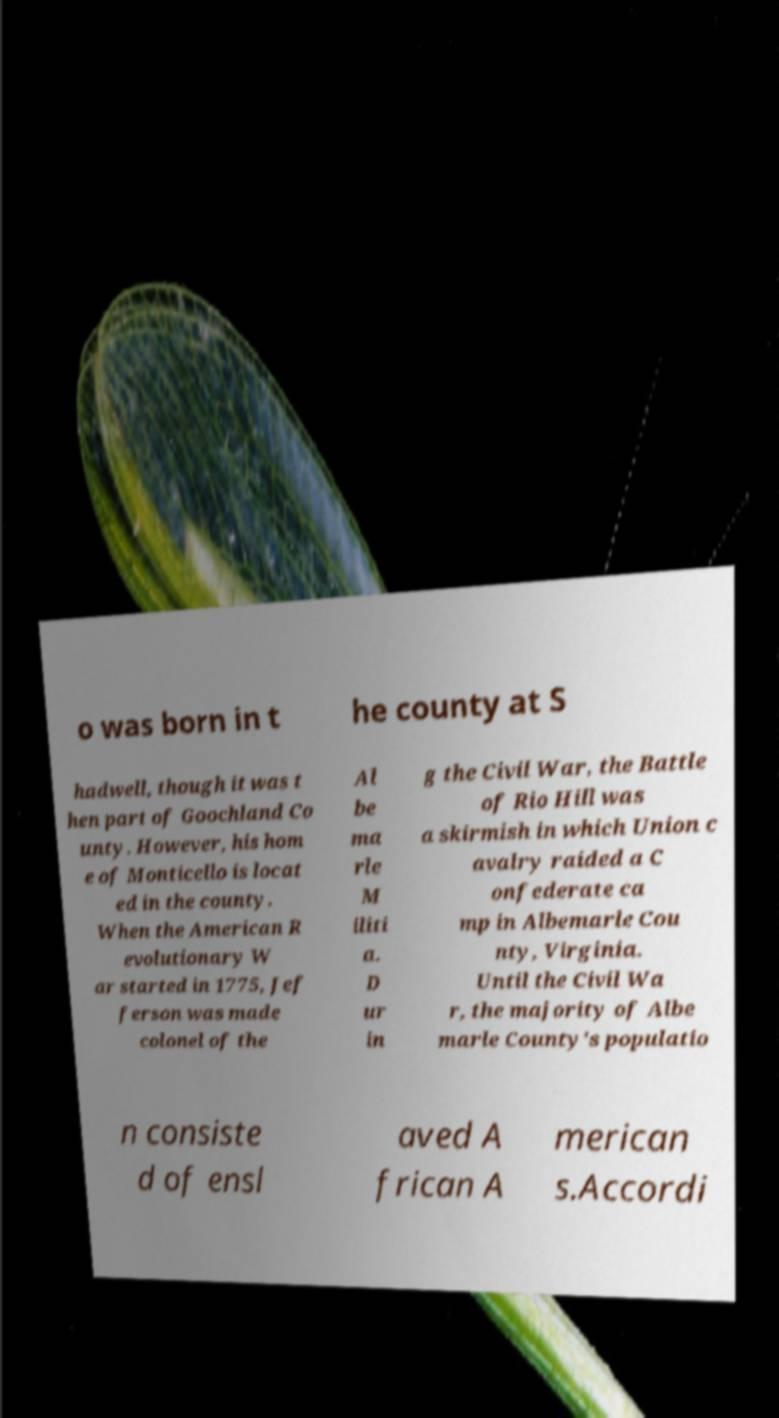For documentation purposes, I need the text within this image transcribed. Could you provide that? o was born in t he county at S hadwell, though it was t hen part of Goochland Co unty. However, his hom e of Monticello is locat ed in the county. When the American R evolutionary W ar started in 1775, Jef ferson was made colonel of the Al be ma rle M iliti a. D ur in g the Civil War, the Battle of Rio Hill was a skirmish in which Union c avalry raided a C onfederate ca mp in Albemarle Cou nty, Virginia. Until the Civil Wa r, the majority of Albe marle County's populatio n consiste d of ensl aved A frican A merican s.Accordi 